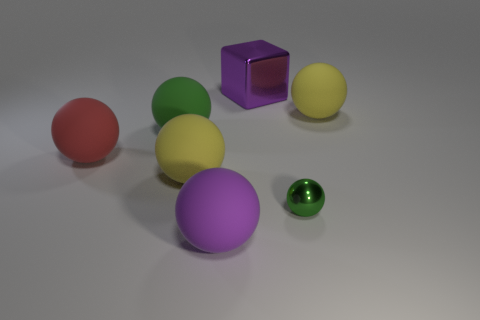Subtract all red spheres. How many spheres are left? 5 Subtract all green shiny balls. How many balls are left? 5 Subtract all yellow blocks. Subtract all brown cylinders. How many blocks are left? 1 Add 2 small objects. How many objects exist? 9 Subtract all balls. How many objects are left? 1 Add 3 large red spheres. How many large red spheres are left? 4 Add 3 tiny spheres. How many tiny spheres exist? 4 Subtract 0 gray cylinders. How many objects are left? 7 Subtract all large purple objects. Subtract all small green metal balls. How many objects are left? 4 